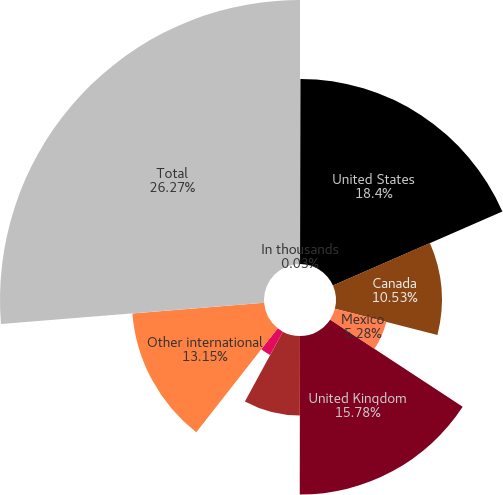Convert chart. <chart><loc_0><loc_0><loc_500><loc_500><pie_chart><fcel>In thousands<fcel>United States<fcel>Canada<fcel>Mexico<fcel>United Kingdom<fcel>Australia<fcel>Germany<fcel>Other international<fcel>Total<nl><fcel>0.03%<fcel>18.4%<fcel>10.53%<fcel>5.28%<fcel>15.78%<fcel>7.9%<fcel>2.66%<fcel>13.15%<fcel>26.27%<nl></chart> 